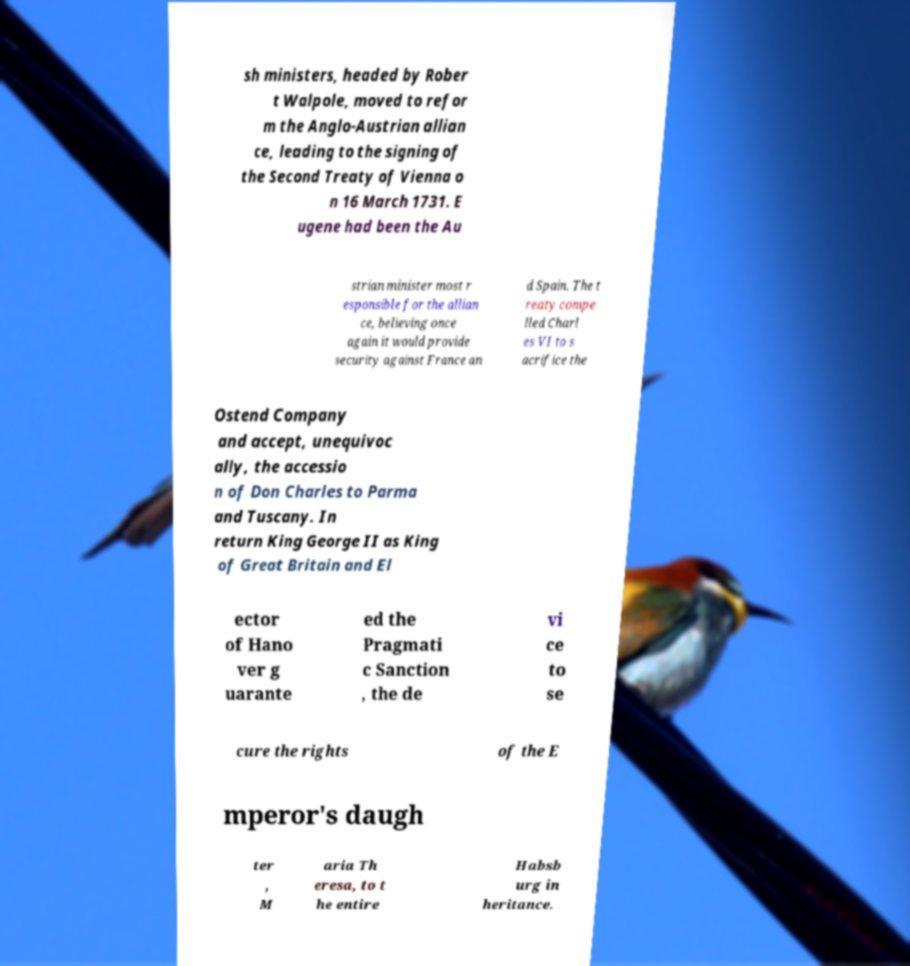What messages or text are displayed in this image? I need them in a readable, typed format. sh ministers, headed by Rober t Walpole, moved to refor m the Anglo-Austrian allian ce, leading to the signing of the Second Treaty of Vienna o n 16 March 1731. E ugene had been the Au strian minister most r esponsible for the allian ce, believing once again it would provide security against France an d Spain. The t reaty compe lled Charl es VI to s acrifice the Ostend Company and accept, unequivoc ally, the accessio n of Don Charles to Parma and Tuscany. In return King George II as King of Great Britain and El ector of Hano ver g uarante ed the Pragmati c Sanction , the de vi ce to se cure the rights of the E mperor's daugh ter , M aria Th eresa, to t he entire Habsb urg in heritance. 